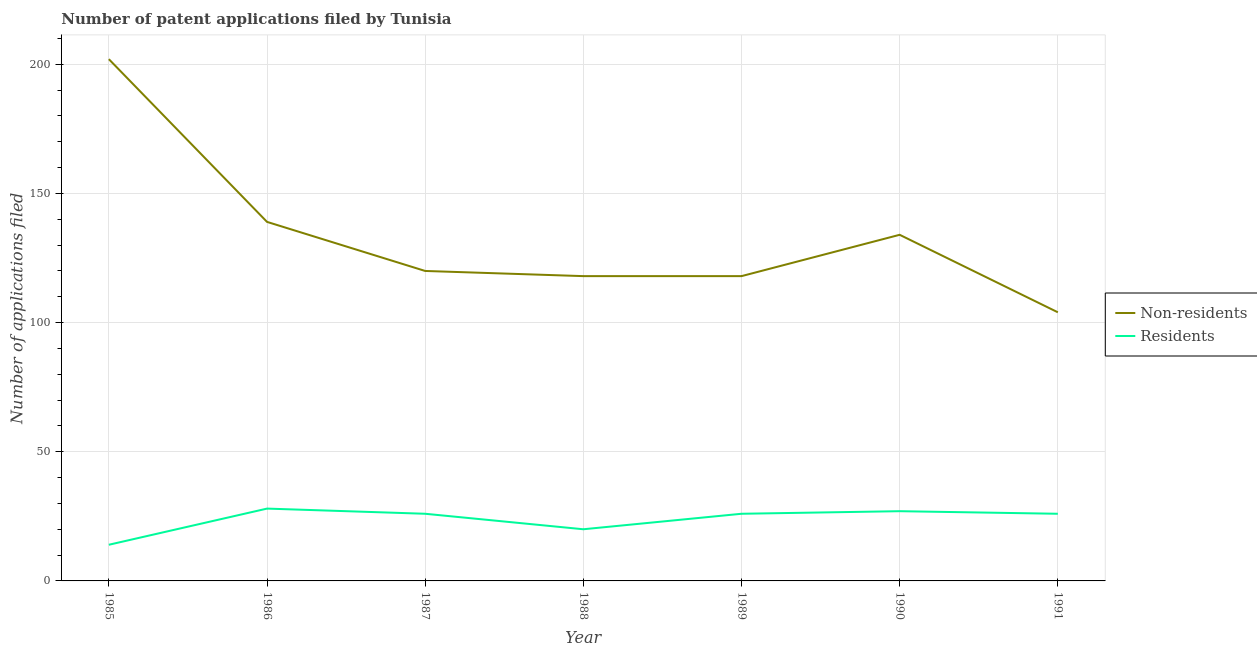Is the number of lines equal to the number of legend labels?
Your answer should be compact. Yes. What is the number of patent applications by residents in 1988?
Ensure brevity in your answer.  20. Across all years, what is the maximum number of patent applications by non residents?
Provide a short and direct response. 202. Across all years, what is the minimum number of patent applications by non residents?
Your answer should be compact. 104. In which year was the number of patent applications by non residents maximum?
Give a very brief answer. 1985. What is the total number of patent applications by residents in the graph?
Offer a terse response. 167. What is the difference between the number of patent applications by non residents in 1987 and that in 1990?
Your response must be concise. -14. What is the difference between the number of patent applications by residents in 1989 and the number of patent applications by non residents in 1990?
Offer a terse response. -108. What is the average number of patent applications by residents per year?
Give a very brief answer. 23.86. In the year 1991, what is the difference between the number of patent applications by residents and number of patent applications by non residents?
Provide a short and direct response. -78. In how many years, is the number of patent applications by non residents greater than 120?
Provide a short and direct response. 3. What is the ratio of the number of patent applications by non residents in 1985 to that in 1989?
Keep it short and to the point. 1.71. What is the difference between the highest and the second highest number of patent applications by residents?
Keep it short and to the point. 1. What is the difference between the highest and the lowest number of patent applications by residents?
Provide a succinct answer. 14. Is the sum of the number of patent applications by residents in 1987 and 1988 greater than the maximum number of patent applications by non residents across all years?
Keep it short and to the point. No. Is the number of patent applications by non residents strictly greater than the number of patent applications by residents over the years?
Ensure brevity in your answer.  Yes. Is the number of patent applications by non residents strictly less than the number of patent applications by residents over the years?
Offer a very short reply. No. How many lines are there?
Your answer should be compact. 2. How many years are there in the graph?
Provide a succinct answer. 7. Does the graph contain grids?
Keep it short and to the point. Yes. What is the title of the graph?
Your response must be concise. Number of patent applications filed by Tunisia. What is the label or title of the X-axis?
Offer a terse response. Year. What is the label or title of the Y-axis?
Make the answer very short. Number of applications filed. What is the Number of applications filed in Non-residents in 1985?
Ensure brevity in your answer.  202. What is the Number of applications filed in Non-residents in 1986?
Offer a very short reply. 139. What is the Number of applications filed in Non-residents in 1987?
Your response must be concise. 120. What is the Number of applications filed in Residents in 1987?
Your answer should be very brief. 26. What is the Number of applications filed of Non-residents in 1988?
Offer a terse response. 118. What is the Number of applications filed in Residents in 1988?
Your response must be concise. 20. What is the Number of applications filed in Non-residents in 1989?
Offer a terse response. 118. What is the Number of applications filed of Residents in 1989?
Give a very brief answer. 26. What is the Number of applications filed in Non-residents in 1990?
Offer a very short reply. 134. What is the Number of applications filed of Non-residents in 1991?
Ensure brevity in your answer.  104. Across all years, what is the maximum Number of applications filed of Non-residents?
Give a very brief answer. 202. Across all years, what is the minimum Number of applications filed of Non-residents?
Give a very brief answer. 104. What is the total Number of applications filed in Non-residents in the graph?
Offer a terse response. 935. What is the total Number of applications filed of Residents in the graph?
Your answer should be very brief. 167. What is the difference between the Number of applications filed of Non-residents in 1985 and that in 1986?
Ensure brevity in your answer.  63. What is the difference between the Number of applications filed in Non-residents in 1985 and that in 1987?
Offer a terse response. 82. What is the difference between the Number of applications filed in Residents in 1985 and that in 1987?
Ensure brevity in your answer.  -12. What is the difference between the Number of applications filed in Residents in 1985 and that in 1988?
Keep it short and to the point. -6. What is the difference between the Number of applications filed of Non-residents in 1985 and that in 1989?
Your answer should be very brief. 84. What is the difference between the Number of applications filed of Non-residents in 1985 and that in 1990?
Give a very brief answer. 68. What is the difference between the Number of applications filed of Non-residents in 1985 and that in 1991?
Keep it short and to the point. 98. What is the difference between the Number of applications filed of Residents in 1985 and that in 1991?
Keep it short and to the point. -12. What is the difference between the Number of applications filed of Residents in 1986 and that in 1989?
Ensure brevity in your answer.  2. What is the difference between the Number of applications filed of Residents in 1986 and that in 1990?
Offer a terse response. 1. What is the difference between the Number of applications filed in Non-residents in 1986 and that in 1991?
Keep it short and to the point. 35. What is the difference between the Number of applications filed of Residents in 1986 and that in 1991?
Offer a very short reply. 2. What is the difference between the Number of applications filed of Non-residents in 1987 and that in 1988?
Make the answer very short. 2. What is the difference between the Number of applications filed of Residents in 1987 and that in 1989?
Give a very brief answer. 0. What is the difference between the Number of applications filed of Non-residents in 1987 and that in 1990?
Ensure brevity in your answer.  -14. What is the difference between the Number of applications filed of Residents in 1987 and that in 1990?
Ensure brevity in your answer.  -1. What is the difference between the Number of applications filed of Residents in 1987 and that in 1991?
Your response must be concise. 0. What is the difference between the Number of applications filed in Non-residents in 1988 and that in 1989?
Ensure brevity in your answer.  0. What is the difference between the Number of applications filed in Non-residents in 1988 and that in 1991?
Ensure brevity in your answer.  14. What is the difference between the Number of applications filed of Residents in 1988 and that in 1991?
Offer a terse response. -6. What is the difference between the Number of applications filed of Non-residents in 1989 and that in 1990?
Keep it short and to the point. -16. What is the difference between the Number of applications filed in Residents in 1989 and that in 1990?
Provide a short and direct response. -1. What is the difference between the Number of applications filed of Non-residents in 1989 and that in 1991?
Offer a very short reply. 14. What is the difference between the Number of applications filed in Residents in 1989 and that in 1991?
Provide a short and direct response. 0. What is the difference between the Number of applications filed of Non-residents in 1985 and the Number of applications filed of Residents in 1986?
Give a very brief answer. 174. What is the difference between the Number of applications filed of Non-residents in 1985 and the Number of applications filed of Residents in 1987?
Your answer should be compact. 176. What is the difference between the Number of applications filed of Non-residents in 1985 and the Number of applications filed of Residents in 1988?
Provide a succinct answer. 182. What is the difference between the Number of applications filed of Non-residents in 1985 and the Number of applications filed of Residents in 1989?
Provide a succinct answer. 176. What is the difference between the Number of applications filed of Non-residents in 1985 and the Number of applications filed of Residents in 1990?
Your response must be concise. 175. What is the difference between the Number of applications filed in Non-residents in 1985 and the Number of applications filed in Residents in 1991?
Your answer should be compact. 176. What is the difference between the Number of applications filed in Non-residents in 1986 and the Number of applications filed in Residents in 1987?
Your response must be concise. 113. What is the difference between the Number of applications filed in Non-residents in 1986 and the Number of applications filed in Residents in 1988?
Your response must be concise. 119. What is the difference between the Number of applications filed of Non-residents in 1986 and the Number of applications filed of Residents in 1989?
Your response must be concise. 113. What is the difference between the Number of applications filed of Non-residents in 1986 and the Number of applications filed of Residents in 1990?
Your answer should be compact. 112. What is the difference between the Number of applications filed in Non-residents in 1986 and the Number of applications filed in Residents in 1991?
Your answer should be compact. 113. What is the difference between the Number of applications filed in Non-residents in 1987 and the Number of applications filed in Residents in 1988?
Provide a short and direct response. 100. What is the difference between the Number of applications filed in Non-residents in 1987 and the Number of applications filed in Residents in 1989?
Your response must be concise. 94. What is the difference between the Number of applications filed of Non-residents in 1987 and the Number of applications filed of Residents in 1990?
Your response must be concise. 93. What is the difference between the Number of applications filed in Non-residents in 1987 and the Number of applications filed in Residents in 1991?
Ensure brevity in your answer.  94. What is the difference between the Number of applications filed of Non-residents in 1988 and the Number of applications filed of Residents in 1989?
Your response must be concise. 92. What is the difference between the Number of applications filed in Non-residents in 1988 and the Number of applications filed in Residents in 1990?
Offer a terse response. 91. What is the difference between the Number of applications filed of Non-residents in 1988 and the Number of applications filed of Residents in 1991?
Provide a succinct answer. 92. What is the difference between the Number of applications filed of Non-residents in 1989 and the Number of applications filed of Residents in 1990?
Provide a short and direct response. 91. What is the difference between the Number of applications filed in Non-residents in 1989 and the Number of applications filed in Residents in 1991?
Your response must be concise. 92. What is the difference between the Number of applications filed in Non-residents in 1990 and the Number of applications filed in Residents in 1991?
Provide a succinct answer. 108. What is the average Number of applications filed of Non-residents per year?
Provide a short and direct response. 133.57. What is the average Number of applications filed of Residents per year?
Keep it short and to the point. 23.86. In the year 1985, what is the difference between the Number of applications filed of Non-residents and Number of applications filed of Residents?
Ensure brevity in your answer.  188. In the year 1986, what is the difference between the Number of applications filed of Non-residents and Number of applications filed of Residents?
Give a very brief answer. 111. In the year 1987, what is the difference between the Number of applications filed of Non-residents and Number of applications filed of Residents?
Provide a short and direct response. 94. In the year 1988, what is the difference between the Number of applications filed of Non-residents and Number of applications filed of Residents?
Your answer should be very brief. 98. In the year 1989, what is the difference between the Number of applications filed in Non-residents and Number of applications filed in Residents?
Offer a very short reply. 92. In the year 1990, what is the difference between the Number of applications filed in Non-residents and Number of applications filed in Residents?
Offer a terse response. 107. In the year 1991, what is the difference between the Number of applications filed of Non-residents and Number of applications filed of Residents?
Your response must be concise. 78. What is the ratio of the Number of applications filed in Non-residents in 1985 to that in 1986?
Give a very brief answer. 1.45. What is the ratio of the Number of applications filed of Non-residents in 1985 to that in 1987?
Keep it short and to the point. 1.68. What is the ratio of the Number of applications filed in Residents in 1985 to that in 1987?
Your answer should be very brief. 0.54. What is the ratio of the Number of applications filed of Non-residents in 1985 to that in 1988?
Offer a very short reply. 1.71. What is the ratio of the Number of applications filed in Non-residents in 1985 to that in 1989?
Offer a terse response. 1.71. What is the ratio of the Number of applications filed of Residents in 1985 to that in 1989?
Make the answer very short. 0.54. What is the ratio of the Number of applications filed of Non-residents in 1985 to that in 1990?
Give a very brief answer. 1.51. What is the ratio of the Number of applications filed in Residents in 1985 to that in 1990?
Make the answer very short. 0.52. What is the ratio of the Number of applications filed of Non-residents in 1985 to that in 1991?
Give a very brief answer. 1.94. What is the ratio of the Number of applications filed in Residents in 1985 to that in 1991?
Provide a succinct answer. 0.54. What is the ratio of the Number of applications filed in Non-residents in 1986 to that in 1987?
Give a very brief answer. 1.16. What is the ratio of the Number of applications filed in Non-residents in 1986 to that in 1988?
Provide a short and direct response. 1.18. What is the ratio of the Number of applications filed of Residents in 1986 to that in 1988?
Offer a terse response. 1.4. What is the ratio of the Number of applications filed of Non-residents in 1986 to that in 1989?
Your answer should be compact. 1.18. What is the ratio of the Number of applications filed in Non-residents in 1986 to that in 1990?
Your answer should be very brief. 1.04. What is the ratio of the Number of applications filed of Residents in 1986 to that in 1990?
Provide a succinct answer. 1.04. What is the ratio of the Number of applications filed in Non-residents in 1986 to that in 1991?
Provide a succinct answer. 1.34. What is the ratio of the Number of applications filed in Residents in 1986 to that in 1991?
Your answer should be compact. 1.08. What is the ratio of the Number of applications filed of Non-residents in 1987 to that in 1988?
Your answer should be very brief. 1.02. What is the ratio of the Number of applications filed in Residents in 1987 to that in 1988?
Provide a short and direct response. 1.3. What is the ratio of the Number of applications filed of Non-residents in 1987 to that in 1989?
Your answer should be very brief. 1.02. What is the ratio of the Number of applications filed in Residents in 1987 to that in 1989?
Keep it short and to the point. 1. What is the ratio of the Number of applications filed of Non-residents in 1987 to that in 1990?
Your response must be concise. 0.9. What is the ratio of the Number of applications filed of Non-residents in 1987 to that in 1991?
Provide a short and direct response. 1.15. What is the ratio of the Number of applications filed of Residents in 1987 to that in 1991?
Your answer should be very brief. 1. What is the ratio of the Number of applications filed of Non-residents in 1988 to that in 1989?
Keep it short and to the point. 1. What is the ratio of the Number of applications filed in Residents in 1988 to that in 1989?
Your answer should be compact. 0.77. What is the ratio of the Number of applications filed in Non-residents in 1988 to that in 1990?
Make the answer very short. 0.88. What is the ratio of the Number of applications filed of Residents in 1988 to that in 1990?
Make the answer very short. 0.74. What is the ratio of the Number of applications filed in Non-residents in 1988 to that in 1991?
Give a very brief answer. 1.13. What is the ratio of the Number of applications filed in Residents in 1988 to that in 1991?
Provide a short and direct response. 0.77. What is the ratio of the Number of applications filed of Non-residents in 1989 to that in 1990?
Offer a terse response. 0.88. What is the ratio of the Number of applications filed of Non-residents in 1989 to that in 1991?
Provide a short and direct response. 1.13. What is the ratio of the Number of applications filed in Residents in 1989 to that in 1991?
Your response must be concise. 1. What is the ratio of the Number of applications filed in Non-residents in 1990 to that in 1991?
Offer a terse response. 1.29. What is the ratio of the Number of applications filed of Residents in 1990 to that in 1991?
Provide a short and direct response. 1.04. 